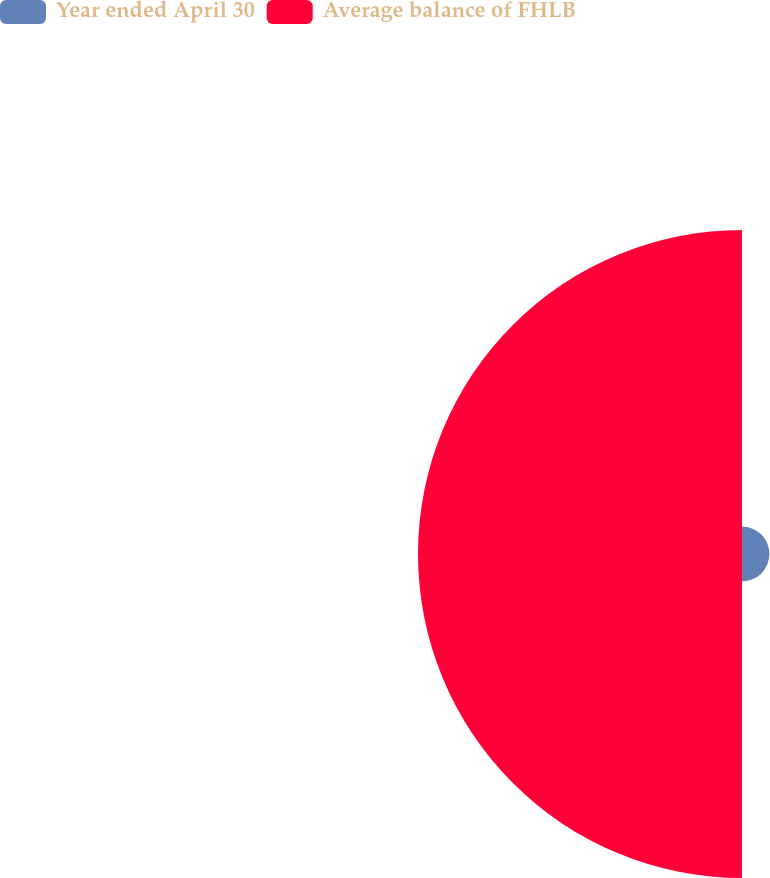<chart> <loc_0><loc_0><loc_500><loc_500><pie_chart><fcel>Year ended April 30<fcel>Average balance of FHLB<nl><fcel>7.8%<fcel>92.2%<nl></chart> 